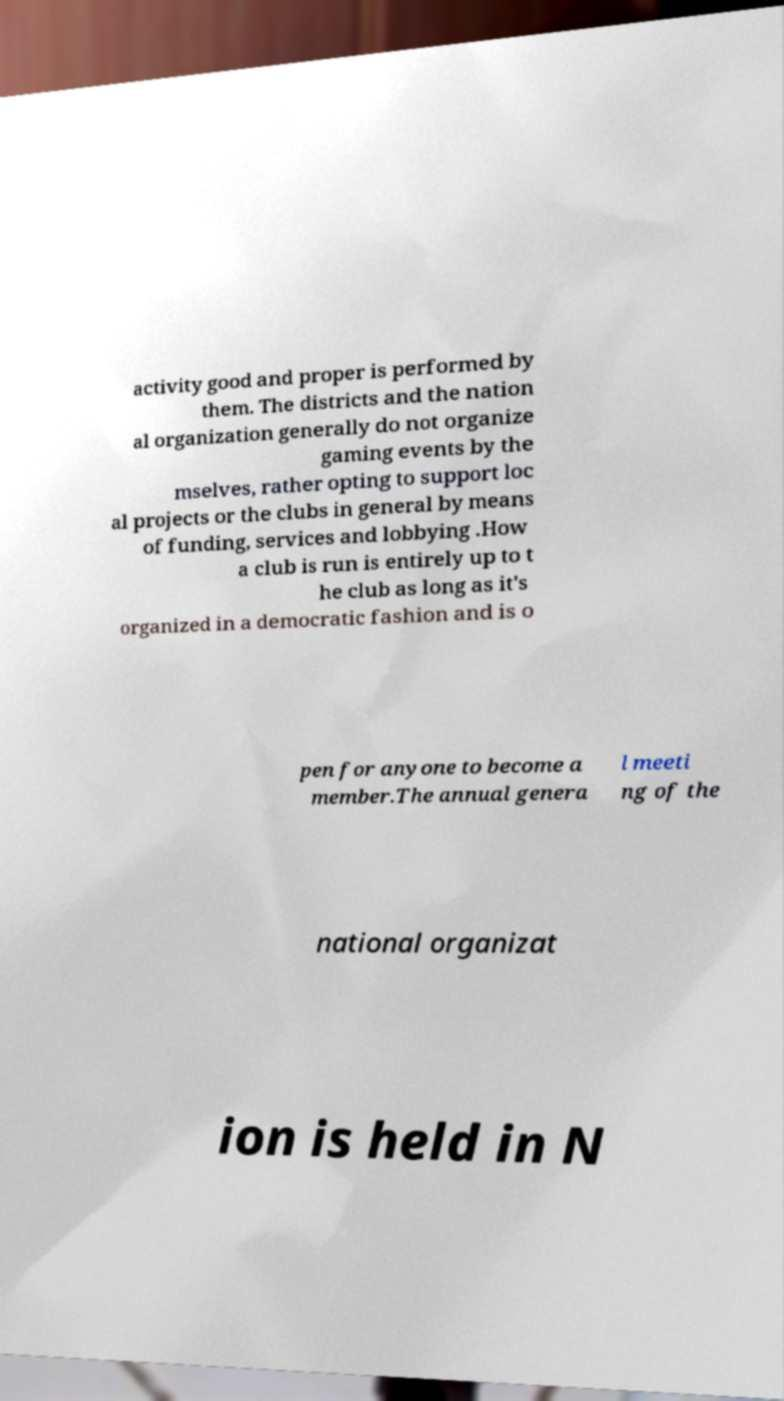There's text embedded in this image that I need extracted. Can you transcribe it verbatim? activity good and proper is performed by them. The districts and the nation al organization generally do not organize gaming events by the mselves, rather opting to support loc al projects or the clubs in general by means of funding, services and lobbying .How a club is run is entirely up to t he club as long as it's organized in a democratic fashion and is o pen for anyone to become a member.The annual genera l meeti ng of the national organizat ion is held in N 